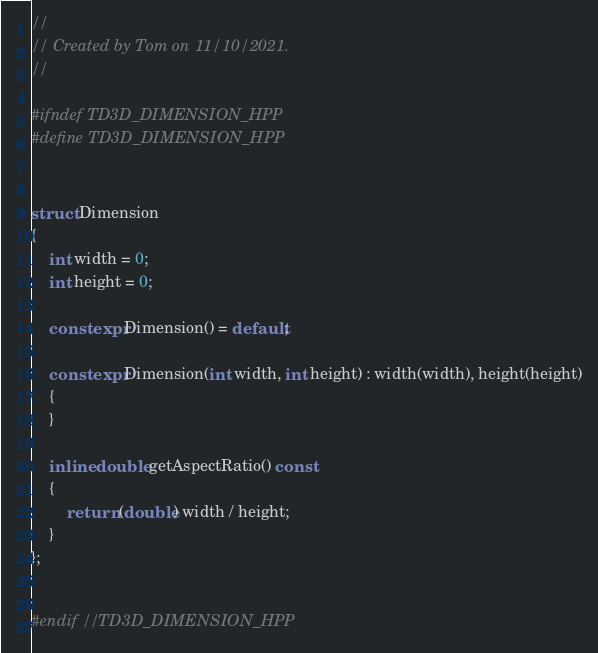Convert code to text. <code><loc_0><loc_0><loc_500><loc_500><_C++_>//
// Created by Tom on 11/10/2021.
//

#ifndef TD3D_DIMENSION_HPP
#define TD3D_DIMENSION_HPP


struct Dimension
{
    int width = 0;
    int height = 0;

    constexpr Dimension() = default;

    constexpr Dimension(int width, int height) : width(width), height(height)
    {
    }

    inline double getAspectRatio() const
    {
        return (double) width / height;
    }
};


#endif //TD3D_DIMENSION_HPP
</code> 